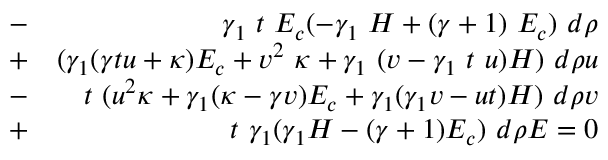<formula> <loc_0><loc_0><loc_500><loc_500>\begin{array} { r l r } & { - } & { \gamma _ { 1 } t E _ { c } ( - \gamma _ { 1 } H + ( \gamma + 1 ) E _ { c } ) d \rho } \\ & { + } & { ( \gamma _ { 1 } ( \gamma t u + \kappa ) E _ { c } + v ^ { 2 } \kappa + \gamma _ { 1 } ( v - \gamma _ { 1 } t u ) H ) d \rho u } \\ & { - } & { t ( u ^ { 2 } \kappa + \gamma _ { 1 } ( \kappa - \gamma v ) E _ { c } + \gamma _ { 1 } ( \gamma _ { 1 } v - u t ) H ) d \rho v } \\ & { + } & { t \gamma _ { 1 } ( \gamma _ { 1 } H - ( \gamma + 1 ) E _ { c } ) d \rho E = 0 } \end{array}</formula> 